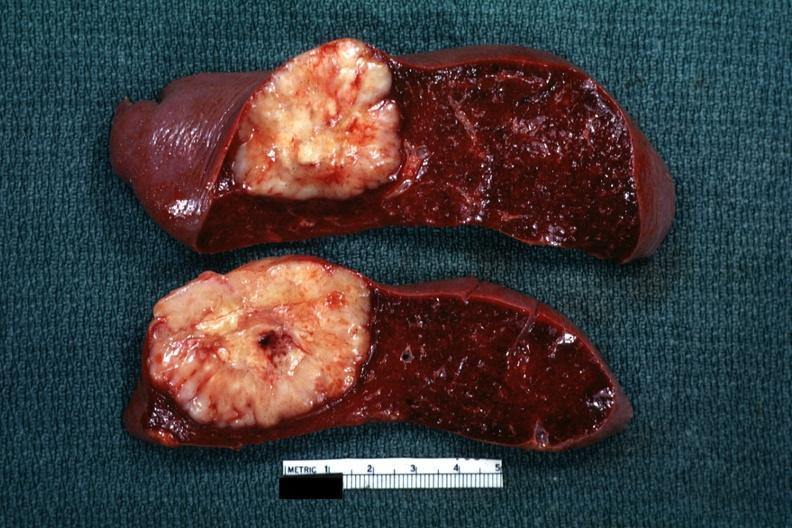what is quite large diagnosis was reticulum cell sarcoma?
Answer the question using a single word or phrase. Single metastatic appearing lesion 